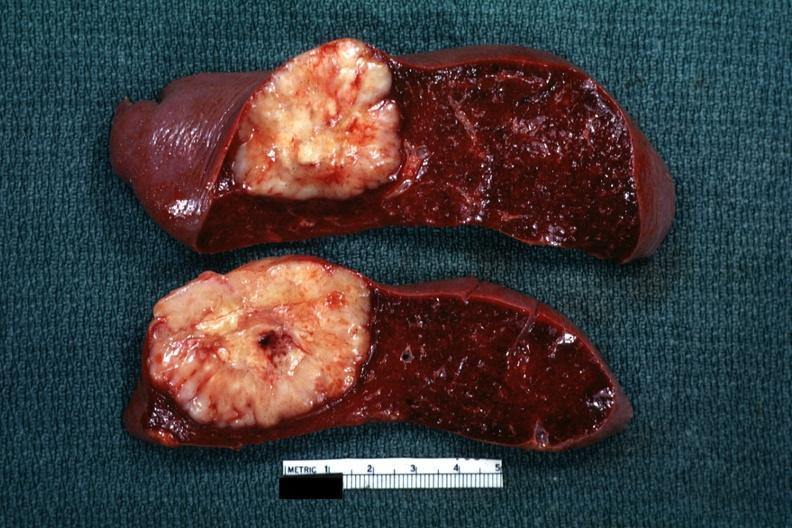what is quite large diagnosis was reticulum cell sarcoma?
Answer the question using a single word or phrase. Single metastatic appearing lesion 